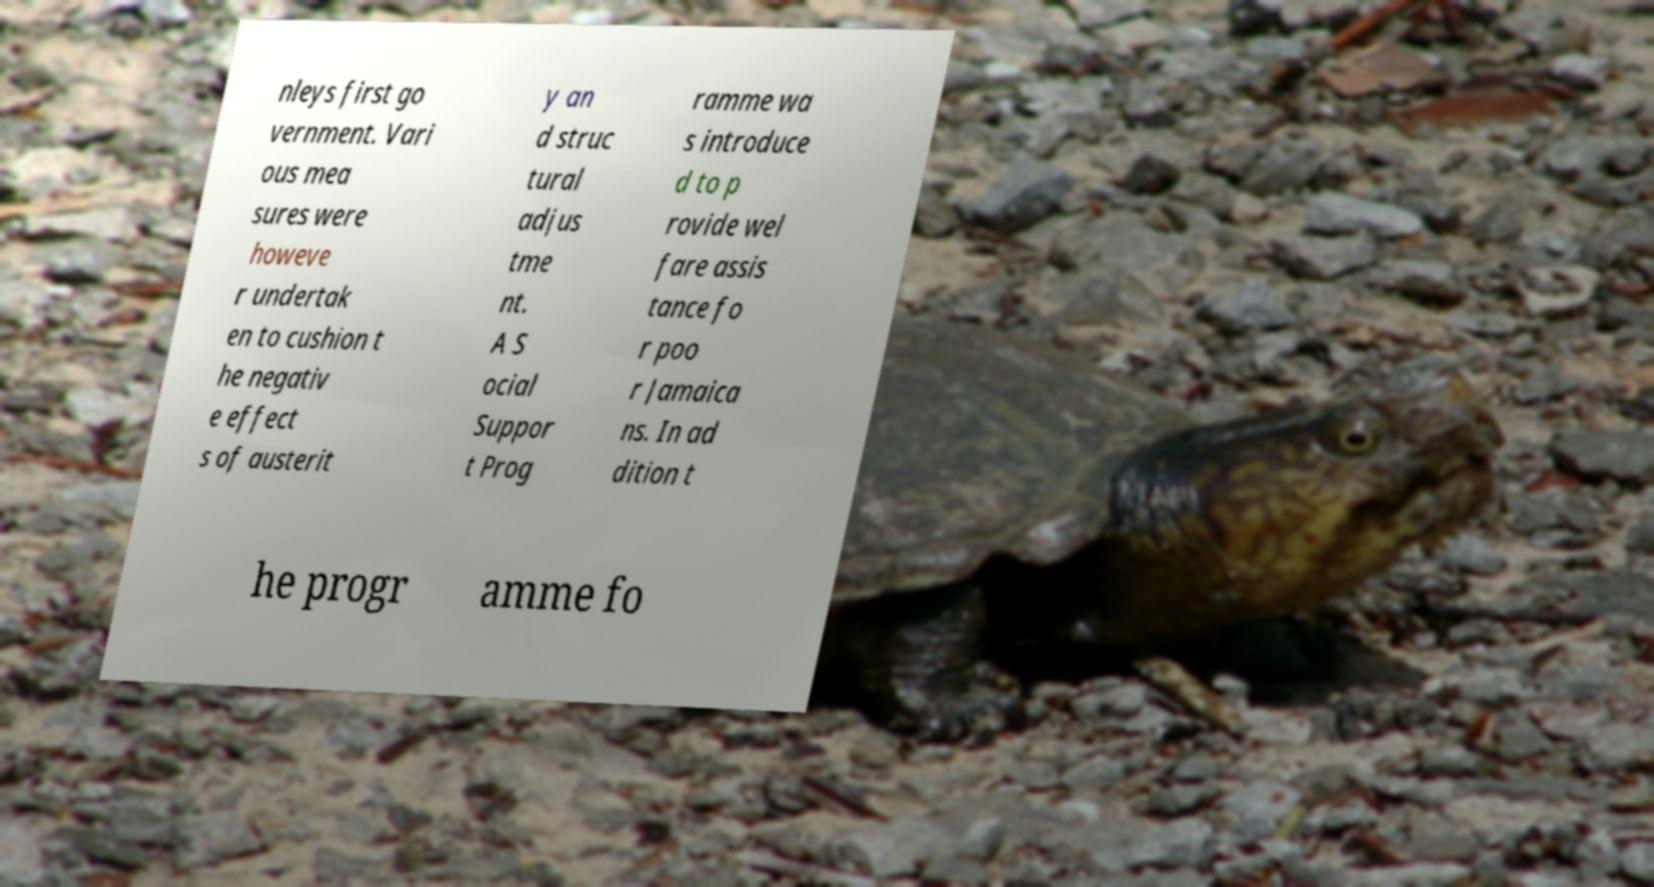There's text embedded in this image that I need extracted. Can you transcribe it verbatim? nleys first go vernment. Vari ous mea sures were howeve r undertak en to cushion t he negativ e effect s of austerit y an d struc tural adjus tme nt. A S ocial Suppor t Prog ramme wa s introduce d to p rovide wel fare assis tance fo r poo r Jamaica ns. In ad dition t he progr amme fo 